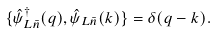Convert formula to latex. <formula><loc_0><loc_0><loc_500><loc_500>\{ \hat { \psi } ^ { \dag } _ { L \bar { n } } ( q ) , \hat { \psi } _ { L \bar { n } } ( k ) \} = \delta ( q - k ) .</formula> 